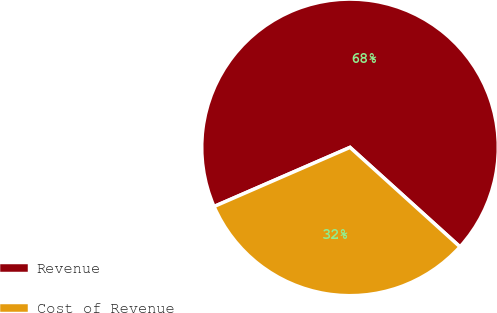<chart> <loc_0><loc_0><loc_500><loc_500><pie_chart><fcel>Revenue<fcel>Cost of Revenue<nl><fcel>68.23%<fcel>31.77%<nl></chart> 